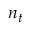Convert formula to latex. <formula><loc_0><loc_0><loc_500><loc_500>n _ { t }</formula> 